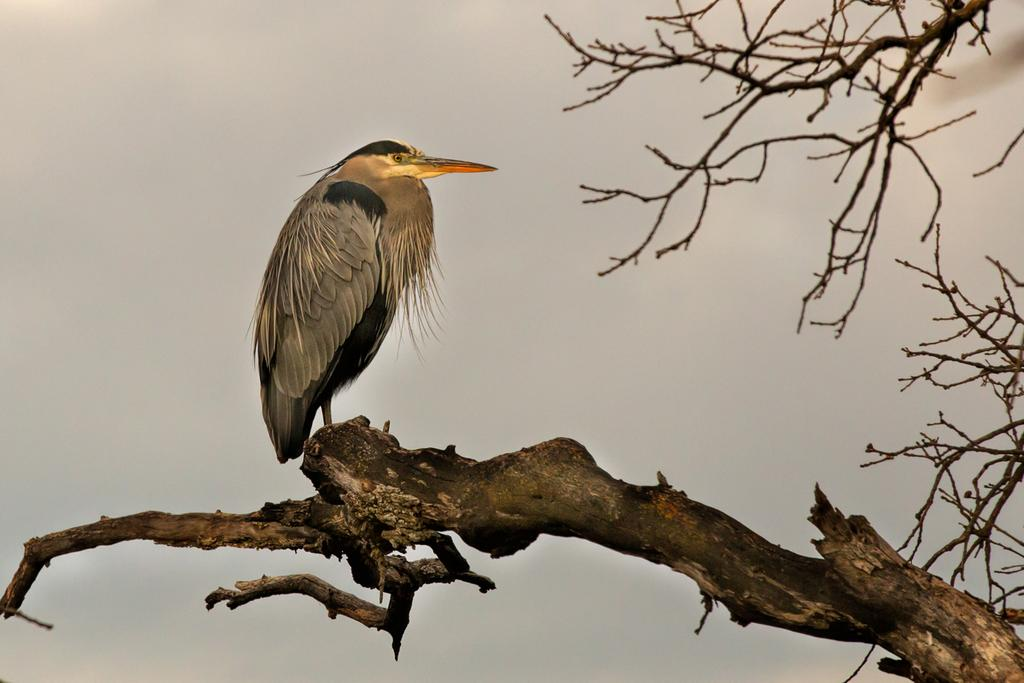What type of animal can be seen in the image? There is a bird in the image. Where is the bird located? The bird is on the branch of a tree. What part of the natural environment is visible in the image? The sky is visible in the image. What type of distribution is the bird making in the image? There is no distribution being made by the bird in the image; it is simply perched on a tree branch. 